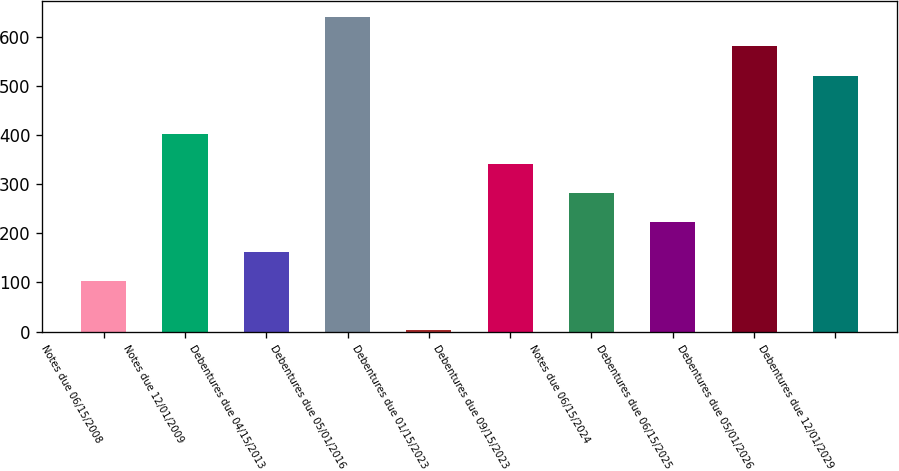Convert chart. <chart><loc_0><loc_0><loc_500><loc_500><bar_chart><fcel>Notes due 06/15/2008<fcel>Notes due 12/01/2009<fcel>Debentures due 04/15/2013<fcel>Debentures due 05/01/2016<fcel>Debentures due 01/15/2023<fcel>Debentures due 09/15/2023<fcel>Notes due 06/15/2024<fcel>Debentures due 06/15/2025<fcel>Debentures due 05/01/2026<fcel>Debentures due 12/01/2029<nl><fcel>103<fcel>401.5<fcel>162.7<fcel>640.3<fcel>3<fcel>341.8<fcel>282.1<fcel>222.4<fcel>580.6<fcel>520.9<nl></chart> 